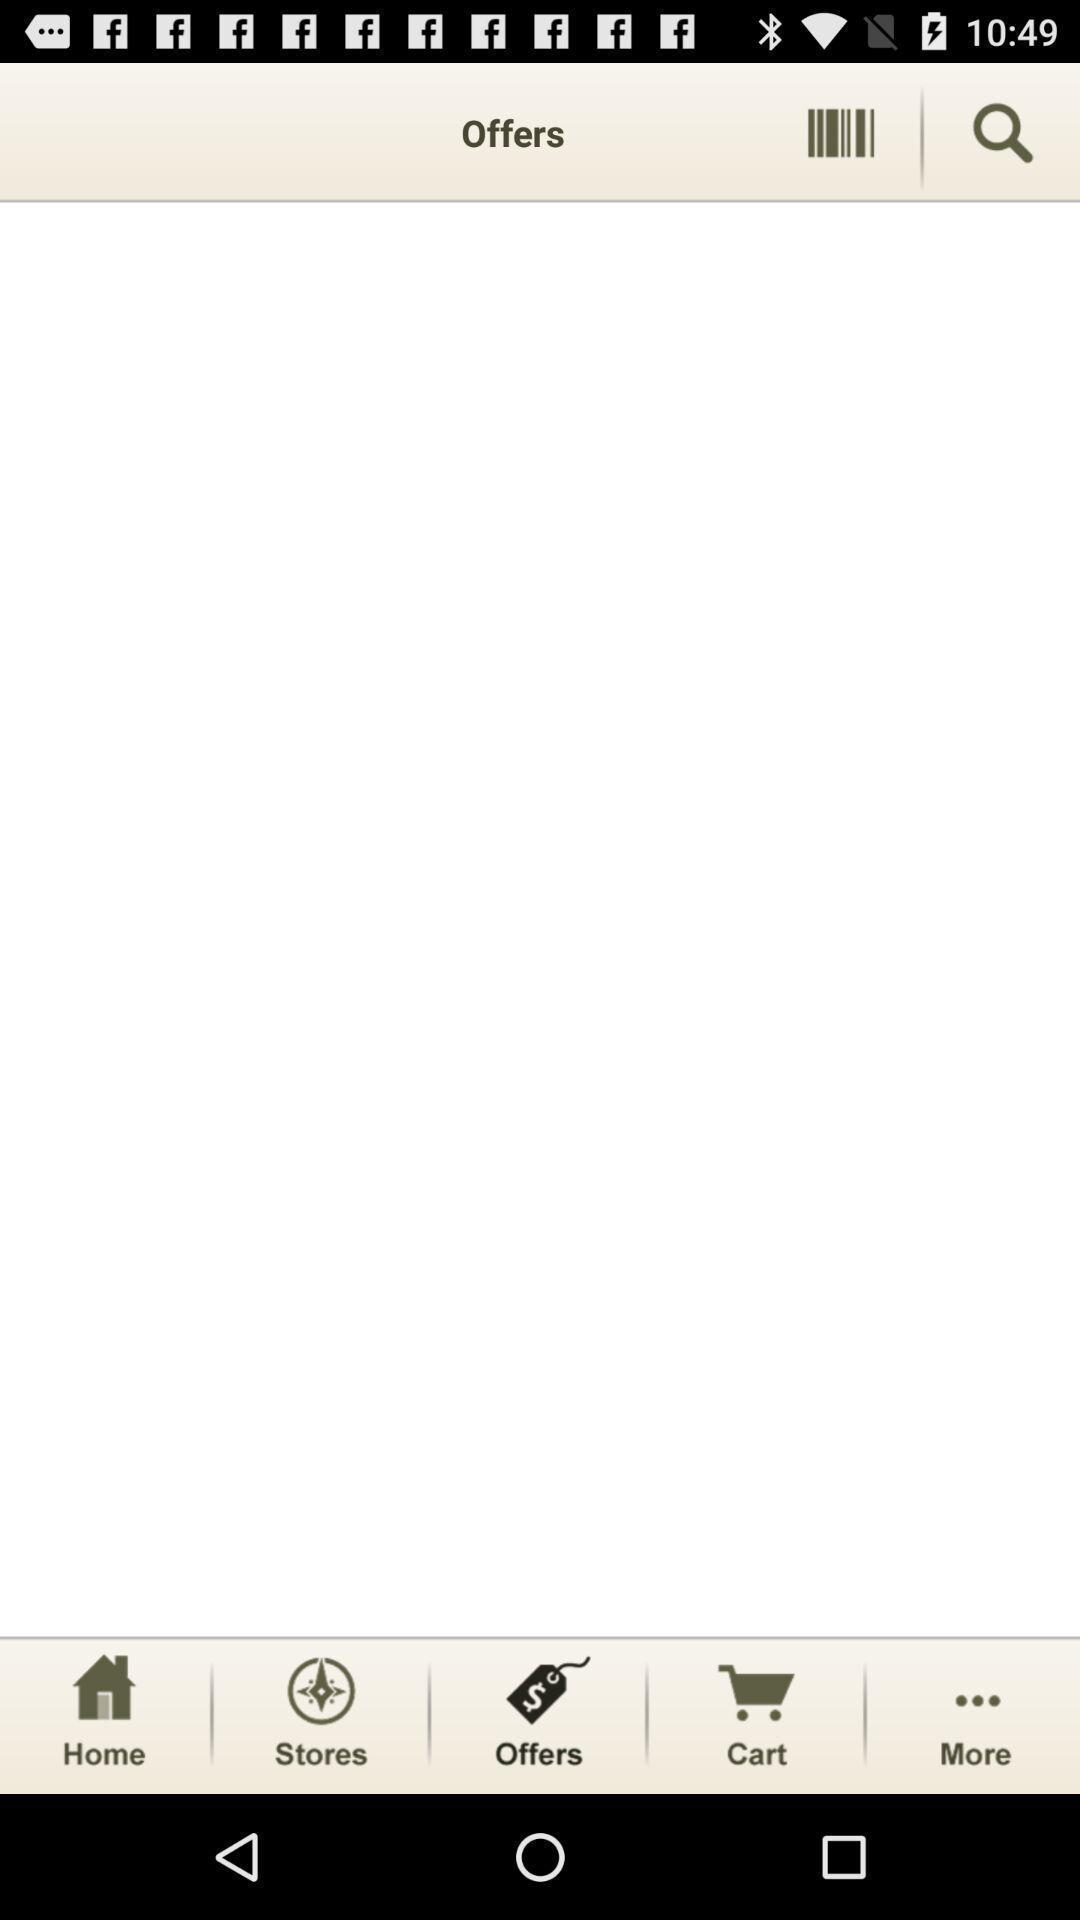What can you discern from this picture? Screen showing offers in an shopping application. 